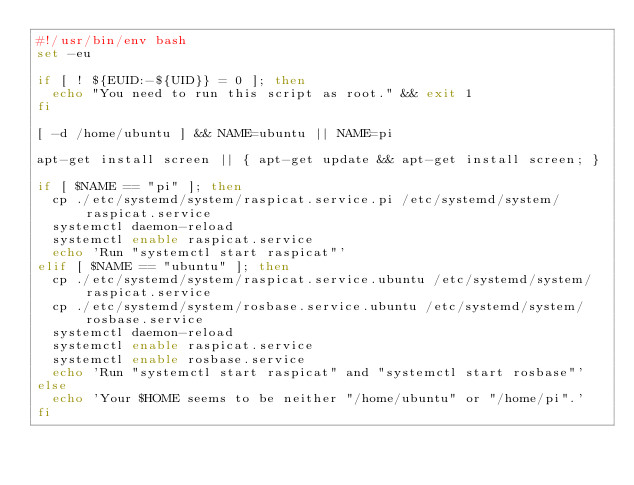Convert code to text. <code><loc_0><loc_0><loc_500><loc_500><_Bash_>#!/usr/bin/env bash
set -eu

if [ ! ${EUID:-${UID}} = 0 ]; then
	echo "You need to run this script as root." && exit 1
fi

[ -d /home/ubuntu ] && NAME=ubuntu || NAME=pi

apt-get install screen || { apt-get update && apt-get install screen; }

if [ $NAME == "pi" ]; then
	cp ./etc/systemd/system/raspicat.service.pi /etc/systemd/system/raspicat.service
	systemctl daemon-reload
	systemctl enable raspicat.service
	echo 'Run "systemctl start raspicat"'
elif [ $NAME == "ubuntu" ]; then
	cp ./etc/systemd/system/raspicat.service.ubuntu /etc/systemd/system/raspicat.service
	cp ./etc/systemd/system/rosbase.service.ubuntu /etc/systemd/system/rosbase.service
	systemctl daemon-reload
	systemctl enable raspicat.service
	systemctl enable rosbase.service
	echo 'Run "systemctl start raspicat" and "systemctl start rosbase"'
else
	echo 'Your $HOME seems to be neither "/home/ubuntu" or "/home/pi".'
fi
</code> 